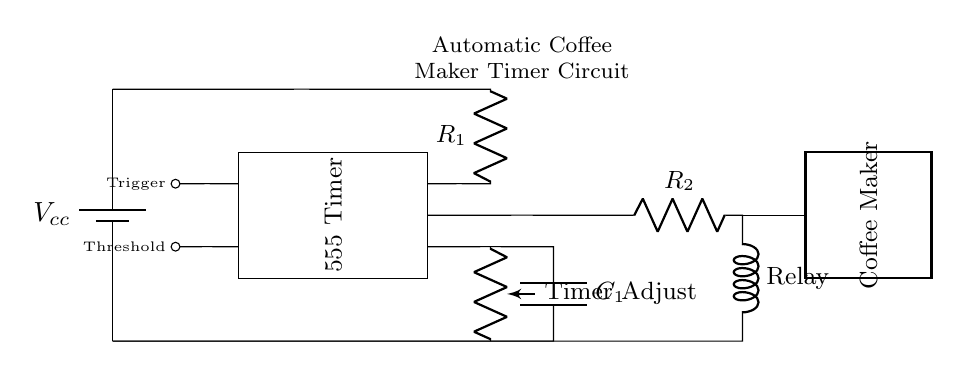What is the main component used for timing in this circuit? The main timing component in this circuit is the 555 Timer, which is a widely used IC for generating precise timing sequences. It is represented as a rectangular block labeled "555 Timer".
Answer: 555 Timer What does the potentiometer labeled "Timer Adjust" control? The potentiometer is used to adjust the timing interval of the circuit. By varying the resistance value, you can change the charging time of the capacitor, which affects how long the coffee maker stays on.
Answer: Timing interval How many resistors are present in the circuit? There are two resistors in the circuit labeled as R1 and R2. One resistor is connected to the output of the 555 Timer, and the other is part of the timing circuit.
Answer: Two What is the function of the relay in the circuit? The relay functions as a switch that controls the power to the coffee maker. When the timer circuit activates, it energizes the relay, allowing current to flow to the coffee maker.
Answer: Switch What happens when the timer reaches its set time? When the timer reaches its set time, the output of the 555 Timer goes high, energizing the relay and turning on the coffee maker for brewing. This is due to the timer triggering the relay to close the circuit to the coffee maker.
Answer: Coffee maker turns on What type of circuit is this an example of? This circuit is an example of an automatic timer circuit specifically designed for industrial appliances like a coffee maker, as it combines timing functions with device control.
Answer: Automatic timer circuit 